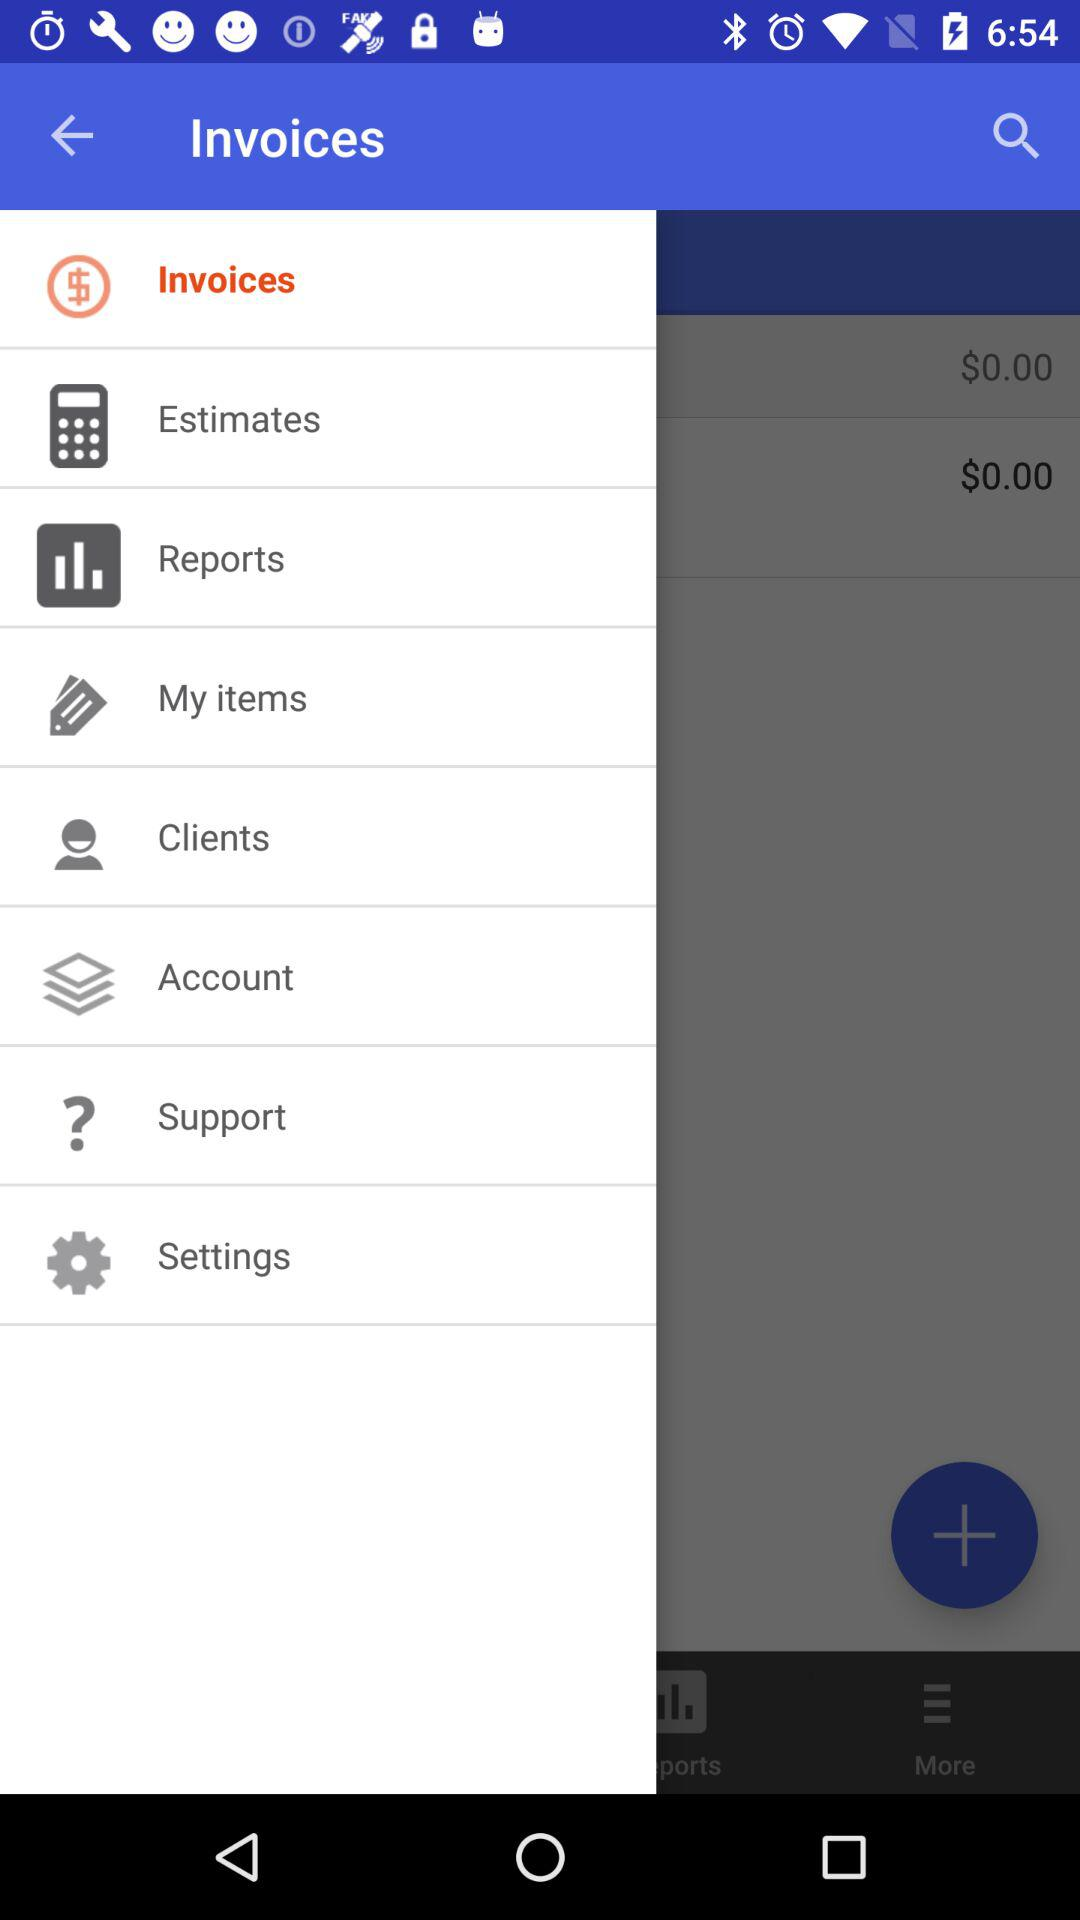What is the name of the application?
When the provided information is insufficient, respond with <no answer>. <no answer> 